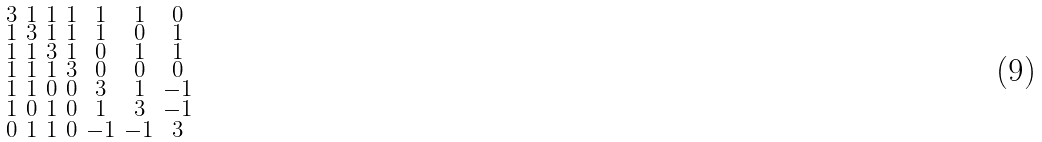Convert formula to latex. <formula><loc_0><loc_0><loc_500><loc_500>\begin{smallmatrix} 3 & 1 & 1 & 1 & 1 & 1 & 0 \\ 1 & 3 & 1 & 1 & 1 & 0 & 1 \\ 1 & 1 & 3 & 1 & 0 & 1 & 1 \\ 1 & 1 & 1 & 3 & 0 & 0 & 0 \\ 1 & 1 & 0 & 0 & 3 & 1 & - 1 \\ 1 & 0 & 1 & 0 & 1 & 3 & - 1 \\ 0 & 1 & 1 & 0 & - 1 & - 1 & 3 \end{smallmatrix}</formula> 